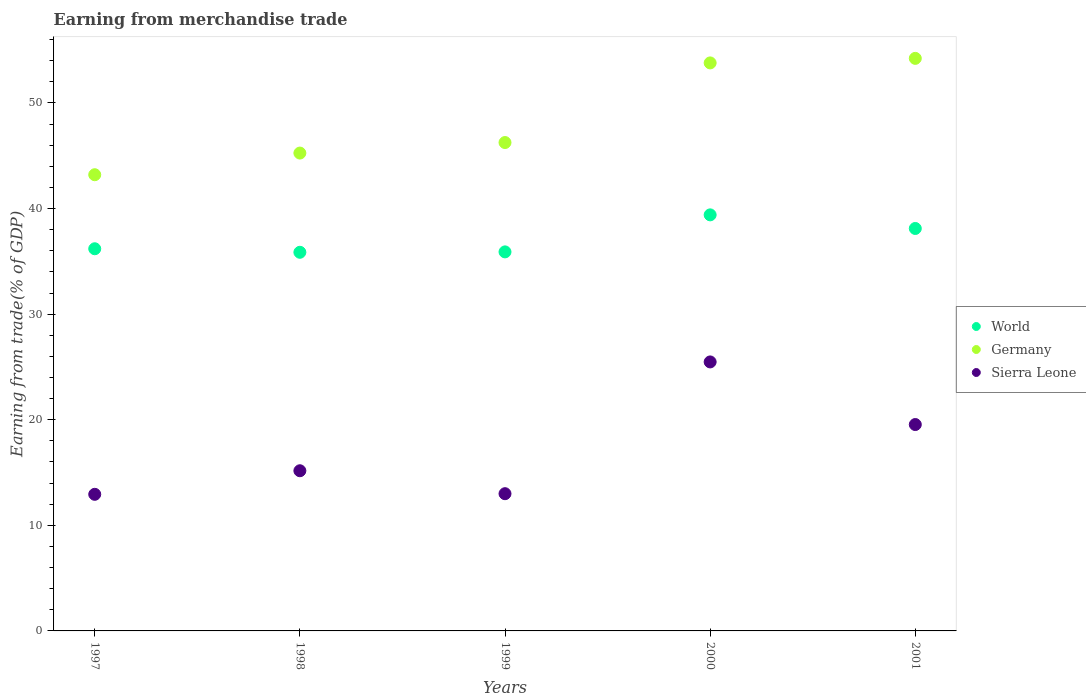Is the number of dotlines equal to the number of legend labels?
Your answer should be very brief. Yes. What is the earnings from trade in World in 1999?
Keep it short and to the point. 35.9. Across all years, what is the maximum earnings from trade in Sierra Leone?
Provide a succinct answer. 25.48. Across all years, what is the minimum earnings from trade in Germany?
Keep it short and to the point. 43.21. In which year was the earnings from trade in World maximum?
Give a very brief answer. 2000. In which year was the earnings from trade in Sierra Leone minimum?
Provide a short and direct response. 1997. What is the total earnings from trade in Germany in the graph?
Provide a succinct answer. 242.74. What is the difference between the earnings from trade in Sierra Leone in 1998 and that in 1999?
Offer a very short reply. 2.17. What is the difference between the earnings from trade in Germany in 1999 and the earnings from trade in Sierra Leone in 2001?
Offer a very short reply. 26.71. What is the average earnings from trade in Germany per year?
Give a very brief answer. 48.55. In the year 2000, what is the difference between the earnings from trade in World and earnings from trade in Sierra Leone?
Your answer should be very brief. 13.93. In how many years, is the earnings from trade in World greater than 38 %?
Give a very brief answer. 2. What is the ratio of the earnings from trade in Sierra Leone in 1997 to that in 1998?
Make the answer very short. 0.85. Is the earnings from trade in Sierra Leone in 1997 less than that in 2000?
Offer a very short reply. Yes. What is the difference between the highest and the second highest earnings from trade in World?
Ensure brevity in your answer.  1.29. What is the difference between the highest and the lowest earnings from trade in World?
Provide a succinct answer. 3.54. In how many years, is the earnings from trade in World greater than the average earnings from trade in World taken over all years?
Offer a terse response. 2. Is the earnings from trade in World strictly less than the earnings from trade in Sierra Leone over the years?
Keep it short and to the point. No. What is the difference between two consecutive major ticks on the Y-axis?
Provide a succinct answer. 10. Does the graph contain any zero values?
Offer a very short reply. No. Does the graph contain grids?
Ensure brevity in your answer.  No. What is the title of the graph?
Provide a short and direct response. Earning from merchandise trade. Does "Algeria" appear as one of the legend labels in the graph?
Your answer should be compact. No. What is the label or title of the X-axis?
Make the answer very short. Years. What is the label or title of the Y-axis?
Provide a succinct answer. Earning from trade(% of GDP). What is the Earning from trade(% of GDP) of World in 1997?
Provide a succinct answer. 36.19. What is the Earning from trade(% of GDP) in Germany in 1997?
Your answer should be compact. 43.21. What is the Earning from trade(% of GDP) in Sierra Leone in 1997?
Ensure brevity in your answer.  12.94. What is the Earning from trade(% of GDP) in World in 1998?
Your answer should be compact. 35.86. What is the Earning from trade(% of GDP) in Germany in 1998?
Your response must be concise. 45.26. What is the Earning from trade(% of GDP) of Sierra Leone in 1998?
Keep it short and to the point. 15.17. What is the Earning from trade(% of GDP) in World in 1999?
Ensure brevity in your answer.  35.9. What is the Earning from trade(% of GDP) of Germany in 1999?
Give a very brief answer. 46.25. What is the Earning from trade(% of GDP) in Sierra Leone in 1999?
Keep it short and to the point. 13. What is the Earning from trade(% of GDP) in World in 2000?
Provide a succinct answer. 39.41. What is the Earning from trade(% of GDP) in Germany in 2000?
Your answer should be compact. 53.8. What is the Earning from trade(% of GDP) in Sierra Leone in 2000?
Keep it short and to the point. 25.48. What is the Earning from trade(% of GDP) of World in 2001?
Provide a succinct answer. 38.12. What is the Earning from trade(% of GDP) in Germany in 2001?
Provide a short and direct response. 54.23. What is the Earning from trade(% of GDP) in Sierra Leone in 2001?
Keep it short and to the point. 19.55. Across all years, what is the maximum Earning from trade(% of GDP) in World?
Your answer should be compact. 39.41. Across all years, what is the maximum Earning from trade(% of GDP) in Germany?
Ensure brevity in your answer.  54.23. Across all years, what is the maximum Earning from trade(% of GDP) in Sierra Leone?
Your answer should be very brief. 25.48. Across all years, what is the minimum Earning from trade(% of GDP) of World?
Your answer should be compact. 35.86. Across all years, what is the minimum Earning from trade(% of GDP) of Germany?
Your answer should be very brief. 43.21. Across all years, what is the minimum Earning from trade(% of GDP) in Sierra Leone?
Your answer should be very brief. 12.94. What is the total Earning from trade(% of GDP) of World in the graph?
Make the answer very short. 185.47. What is the total Earning from trade(% of GDP) of Germany in the graph?
Give a very brief answer. 242.74. What is the total Earning from trade(% of GDP) of Sierra Leone in the graph?
Make the answer very short. 86.13. What is the difference between the Earning from trade(% of GDP) in World in 1997 and that in 1998?
Give a very brief answer. 0.33. What is the difference between the Earning from trade(% of GDP) of Germany in 1997 and that in 1998?
Offer a terse response. -2.05. What is the difference between the Earning from trade(% of GDP) of Sierra Leone in 1997 and that in 1998?
Keep it short and to the point. -2.23. What is the difference between the Earning from trade(% of GDP) in World in 1997 and that in 1999?
Ensure brevity in your answer.  0.3. What is the difference between the Earning from trade(% of GDP) in Germany in 1997 and that in 1999?
Keep it short and to the point. -3.05. What is the difference between the Earning from trade(% of GDP) of Sierra Leone in 1997 and that in 1999?
Your answer should be very brief. -0.06. What is the difference between the Earning from trade(% of GDP) in World in 1997 and that in 2000?
Your response must be concise. -3.21. What is the difference between the Earning from trade(% of GDP) in Germany in 1997 and that in 2000?
Provide a short and direct response. -10.59. What is the difference between the Earning from trade(% of GDP) in Sierra Leone in 1997 and that in 2000?
Ensure brevity in your answer.  -12.54. What is the difference between the Earning from trade(% of GDP) in World in 1997 and that in 2001?
Give a very brief answer. -1.92. What is the difference between the Earning from trade(% of GDP) of Germany in 1997 and that in 2001?
Provide a short and direct response. -11.02. What is the difference between the Earning from trade(% of GDP) in Sierra Leone in 1997 and that in 2001?
Provide a succinct answer. -6.61. What is the difference between the Earning from trade(% of GDP) of World in 1998 and that in 1999?
Ensure brevity in your answer.  -0.04. What is the difference between the Earning from trade(% of GDP) of Germany in 1998 and that in 1999?
Your response must be concise. -1. What is the difference between the Earning from trade(% of GDP) of Sierra Leone in 1998 and that in 1999?
Ensure brevity in your answer.  2.17. What is the difference between the Earning from trade(% of GDP) of World in 1998 and that in 2000?
Keep it short and to the point. -3.54. What is the difference between the Earning from trade(% of GDP) of Germany in 1998 and that in 2000?
Your answer should be compact. -8.54. What is the difference between the Earning from trade(% of GDP) of Sierra Leone in 1998 and that in 2000?
Make the answer very short. -10.31. What is the difference between the Earning from trade(% of GDP) in World in 1998 and that in 2001?
Make the answer very short. -2.25. What is the difference between the Earning from trade(% of GDP) in Germany in 1998 and that in 2001?
Your answer should be very brief. -8.97. What is the difference between the Earning from trade(% of GDP) of Sierra Leone in 1998 and that in 2001?
Your answer should be compact. -4.38. What is the difference between the Earning from trade(% of GDP) of World in 1999 and that in 2000?
Give a very brief answer. -3.51. What is the difference between the Earning from trade(% of GDP) of Germany in 1999 and that in 2000?
Your answer should be very brief. -7.54. What is the difference between the Earning from trade(% of GDP) of Sierra Leone in 1999 and that in 2000?
Keep it short and to the point. -12.48. What is the difference between the Earning from trade(% of GDP) in World in 1999 and that in 2001?
Offer a very short reply. -2.22. What is the difference between the Earning from trade(% of GDP) of Germany in 1999 and that in 2001?
Ensure brevity in your answer.  -7.97. What is the difference between the Earning from trade(% of GDP) in Sierra Leone in 1999 and that in 2001?
Provide a short and direct response. -6.55. What is the difference between the Earning from trade(% of GDP) of World in 2000 and that in 2001?
Make the answer very short. 1.29. What is the difference between the Earning from trade(% of GDP) of Germany in 2000 and that in 2001?
Keep it short and to the point. -0.43. What is the difference between the Earning from trade(% of GDP) of Sierra Leone in 2000 and that in 2001?
Your answer should be compact. 5.93. What is the difference between the Earning from trade(% of GDP) of World in 1997 and the Earning from trade(% of GDP) of Germany in 1998?
Offer a very short reply. -9.06. What is the difference between the Earning from trade(% of GDP) in World in 1997 and the Earning from trade(% of GDP) in Sierra Leone in 1998?
Make the answer very short. 21.02. What is the difference between the Earning from trade(% of GDP) of Germany in 1997 and the Earning from trade(% of GDP) of Sierra Leone in 1998?
Offer a terse response. 28.04. What is the difference between the Earning from trade(% of GDP) of World in 1997 and the Earning from trade(% of GDP) of Germany in 1999?
Make the answer very short. -10.06. What is the difference between the Earning from trade(% of GDP) of World in 1997 and the Earning from trade(% of GDP) of Sierra Leone in 1999?
Your answer should be very brief. 23.2. What is the difference between the Earning from trade(% of GDP) in Germany in 1997 and the Earning from trade(% of GDP) in Sierra Leone in 1999?
Keep it short and to the point. 30.21. What is the difference between the Earning from trade(% of GDP) in World in 1997 and the Earning from trade(% of GDP) in Germany in 2000?
Give a very brief answer. -17.6. What is the difference between the Earning from trade(% of GDP) of World in 1997 and the Earning from trade(% of GDP) of Sierra Leone in 2000?
Provide a short and direct response. 10.72. What is the difference between the Earning from trade(% of GDP) in Germany in 1997 and the Earning from trade(% of GDP) in Sierra Leone in 2000?
Offer a terse response. 17.73. What is the difference between the Earning from trade(% of GDP) in World in 1997 and the Earning from trade(% of GDP) in Germany in 2001?
Your answer should be very brief. -18.03. What is the difference between the Earning from trade(% of GDP) in World in 1997 and the Earning from trade(% of GDP) in Sierra Leone in 2001?
Your answer should be compact. 16.65. What is the difference between the Earning from trade(% of GDP) in Germany in 1997 and the Earning from trade(% of GDP) in Sierra Leone in 2001?
Give a very brief answer. 23.66. What is the difference between the Earning from trade(% of GDP) of World in 1998 and the Earning from trade(% of GDP) of Germany in 1999?
Make the answer very short. -10.39. What is the difference between the Earning from trade(% of GDP) in World in 1998 and the Earning from trade(% of GDP) in Sierra Leone in 1999?
Your answer should be very brief. 22.86. What is the difference between the Earning from trade(% of GDP) in Germany in 1998 and the Earning from trade(% of GDP) in Sierra Leone in 1999?
Your answer should be very brief. 32.26. What is the difference between the Earning from trade(% of GDP) in World in 1998 and the Earning from trade(% of GDP) in Germany in 2000?
Ensure brevity in your answer.  -17.94. What is the difference between the Earning from trade(% of GDP) of World in 1998 and the Earning from trade(% of GDP) of Sierra Leone in 2000?
Your answer should be compact. 10.38. What is the difference between the Earning from trade(% of GDP) of Germany in 1998 and the Earning from trade(% of GDP) of Sierra Leone in 2000?
Make the answer very short. 19.78. What is the difference between the Earning from trade(% of GDP) in World in 1998 and the Earning from trade(% of GDP) in Germany in 2001?
Offer a terse response. -18.37. What is the difference between the Earning from trade(% of GDP) in World in 1998 and the Earning from trade(% of GDP) in Sierra Leone in 2001?
Offer a terse response. 16.31. What is the difference between the Earning from trade(% of GDP) of Germany in 1998 and the Earning from trade(% of GDP) of Sierra Leone in 2001?
Provide a short and direct response. 25.71. What is the difference between the Earning from trade(% of GDP) of World in 1999 and the Earning from trade(% of GDP) of Germany in 2000?
Provide a succinct answer. -17.9. What is the difference between the Earning from trade(% of GDP) in World in 1999 and the Earning from trade(% of GDP) in Sierra Leone in 2000?
Your answer should be compact. 10.42. What is the difference between the Earning from trade(% of GDP) in Germany in 1999 and the Earning from trade(% of GDP) in Sierra Leone in 2000?
Give a very brief answer. 20.78. What is the difference between the Earning from trade(% of GDP) in World in 1999 and the Earning from trade(% of GDP) in Germany in 2001?
Keep it short and to the point. -18.33. What is the difference between the Earning from trade(% of GDP) of World in 1999 and the Earning from trade(% of GDP) of Sierra Leone in 2001?
Provide a short and direct response. 16.35. What is the difference between the Earning from trade(% of GDP) of Germany in 1999 and the Earning from trade(% of GDP) of Sierra Leone in 2001?
Provide a succinct answer. 26.71. What is the difference between the Earning from trade(% of GDP) in World in 2000 and the Earning from trade(% of GDP) in Germany in 2001?
Provide a short and direct response. -14.82. What is the difference between the Earning from trade(% of GDP) of World in 2000 and the Earning from trade(% of GDP) of Sierra Leone in 2001?
Make the answer very short. 19.86. What is the difference between the Earning from trade(% of GDP) of Germany in 2000 and the Earning from trade(% of GDP) of Sierra Leone in 2001?
Your answer should be very brief. 34.25. What is the average Earning from trade(% of GDP) in World per year?
Your response must be concise. 37.09. What is the average Earning from trade(% of GDP) of Germany per year?
Ensure brevity in your answer.  48.55. What is the average Earning from trade(% of GDP) in Sierra Leone per year?
Make the answer very short. 17.23. In the year 1997, what is the difference between the Earning from trade(% of GDP) of World and Earning from trade(% of GDP) of Germany?
Offer a terse response. -7.01. In the year 1997, what is the difference between the Earning from trade(% of GDP) of World and Earning from trade(% of GDP) of Sierra Leone?
Provide a succinct answer. 23.26. In the year 1997, what is the difference between the Earning from trade(% of GDP) of Germany and Earning from trade(% of GDP) of Sierra Leone?
Provide a succinct answer. 30.27. In the year 1998, what is the difference between the Earning from trade(% of GDP) in World and Earning from trade(% of GDP) in Germany?
Keep it short and to the point. -9.4. In the year 1998, what is the difference between the Earning from trade(% of GDP) of World and Earning from trade(% of GDP) of Sierra Leone?
Give a very brief answer. 20.69. In the year 1998, what is the difference between the Earning from trade(% of GDP) in Germany and Earning from trade(% of GDP) in Sierra Leone?
Keep it short and to the point. 30.09. In the year 1999, what is the difference between the Earning from trade(% of GDP) in World and Earning from trade(% of GDP) in Germany?
Offer a terse response. -10.36. In the year 1999, what is the difference between the Earning from trade(% of GDP) of World and Earning from trade(% of GDP) of Sierra Leone?
Your answer should be very brief. 22.9. In the year 1999, what is the difference between the Earning from trade(% of GDP) of Germany and Earning from trade(% of GDP) of Sierra Leone?
Offer a very short reply. 33.26. In the year 2000, what is the difference between the Earning from trade(% of GDP) in World and Earning from trade(% of GDP) in Germany?
Keep it short and to the point. -14.39. In the year 2000, what is the difference between the Earning from trade(% of GDP) of World and Earning from trade(% of GDP) of Sierra Leone?
Give a very brief answer. 13.93. In the year 2000, what is the difference between the Earning from trade(% of GDP) of Germany and Earning from trade(% of GDP) of Sierra Leone?
Give a very brief answer. 28.32. In the year 2001, what is the difference between the Earning from trade(% of GDP) of World and Earning from trade(% of GDP) of Germany?
Provide a short and direct response. -16.11. In the year 2001, what is the difference between the Earning from trade(% of GDP) in World and Earning from trade(% of GDP) in Sierra Leone?
Offer a terse response. 18.57. In the year 2001, what is the difference between the Earning from trade(% of GDP) of Germany and Earning from trade(% of GDP) of Sierra Leone?
Ensure brevity in your answer.  34.68. What is the ratio of the Earning from trade(% of GDP) of World in 1997 to that in 1998?
Make the answer very short. 1.01. What is the ratio of the Earning from trade(% of GDP) of Germany in 1997 to that in 1998?
Your answer should be compact. 0.95. What is the ratio of the Earning from trade(% of GDP) of Sierra Leone in 1997 to that in 1998?
Provide a short and direct response. 0.85. What is the ratio of the Earning from trade(% of GDP) in World in 1997 to that in 1999?
Your answer should be compact. 1.01. What is the ratio of the Earning from trade(% of GDP) of Germany in 1997 to that in 1999?
Ensure brevity in your answer.  0.93. What is the ratio of the Earning from trade(% of GDP) of World in 1997 to that in 2000?
Your answer should be compact. 0.92. What is the ratio of the Earning from trade(% of GDP) in Germany in 1997 to that in 2000?
Offer a very short reply. 0.8. What is the ratio of the Earning from trade(% of GDP) of Sierra Leone in 1997 to that in 2000?
Provide a short and direct response. 0.51. What is the ratio of the Earning from trade(% of GDP) in World in 1997 to that in 2001?
Make the answer very short. 0.95. What is the ratio of the Earning from trade(% of GDP) of Germany in 1997 to that in 2001?
Your answer should be very brief. 0.8. What is the ratio of the Earning from trade(% of GDP) in Sierra Leone in 1997 to that in 2001?
Provide a succinct answer. 0.66. What is the ratio of the Earning from trade(% of GDP) in World in 1998 to that in 1999?
Offer a terse response. 1. What is the ratio of the Earning from trade(% of GDP) in Germany in 1998 to that in 1999?
Keep it short and to the point. 0.98. What is the ratio of the Earning from trade(% of GDP) in Sierra Leone in 1998 to that in 1999?
Provide a succinct answer. 1.17. What is the ratio of the Earning from trade(% of GDP) of World in 1998 to that in 2000?
Offer a very short reply. 0.91. What is the ratio of the Earning from trade(% of GDP) in Germany in 1998 to that in 2000?
Keep it short and to the point. 0.84. What is the ratio of the Earning from trade(% of GDP) in Sierra Leone in 1998 to that in 2000?
Provide a succinct answer. 0.6. What is the ratio of the Earning from trade(% of GDP) in World in 1998 to that in 2001?
Provide a short and direct response. 0.94. What is the ratio of the Earning from trade(% of GDP) of Germany in 1998 to that in 2001?
Your response must be concise. 0.83. What is the ratio of the Earning from trade(% of GDP) in Sierra Leone in 1998 to that in 2001?
Your answer should be compact. 0.78. What is the ratio of the Earning from trade(% of GDP) in World in 1999 to that in 2000?
Make the answer very short. 0.91. What is the ratio of the Earning from trade(% of GDP) in Germany in 1999 to that in 2000?
Your response must be concise. 0.86. What is the ratio of the Earning from trade(% of GDP) of Sierra Leone in 1999 to that in 2000?
Your answer should be compact. 0.51. What is the ratio of the Earning from trade(% of GDP) of World in 1999 to that in 2001?
Ensure brevity in your answer.  0.94. What is the ratio of the Earning from trade(% of GDP) in Germany in 1999 to that in 2001?
Offer a very short reply. 0.85. What is the ratio of the Earning from trade(% of GDP) in Sierra Leone in 1999 to that in 2001?
Make the answer very short. 0.66. What is the ratio of the Earning from trade(% of GDP) in World in 2000 to that in 2001?
Your answer should be compact. 1.03. What is the ratio of the Earning from trade(% of GDP) in Sierra Leone in 2000 to that in 2001?
Make the answer very short. 1.3. What is the difference between the highest and the second highest Earning from trade(% of GDP) of World?
Give a very brief answer. 1.29. What is the difference between the highest and the second highest Earning from trade(% of GDP) of Germany?
Provide a succinct answer. 0.43. What is the difference between the highest and the second highest Earning from trade(% of GDP) in Sierra Leone?
Offer a terse response. 5.93. What is the difference between the highest and the lowest Earning from trade(% of GDP) of World?
Your answer should be very brief. 3.54. What is the difference between the highest and the lowest Earning from trade(% of GDP) of Germany?
Your answer should be very brief. 11.02. What is the difference between the highest and the lowest Earning from trade(% of GDP) of Sierra Leone?
Provide a succinct answer. 12.54. 